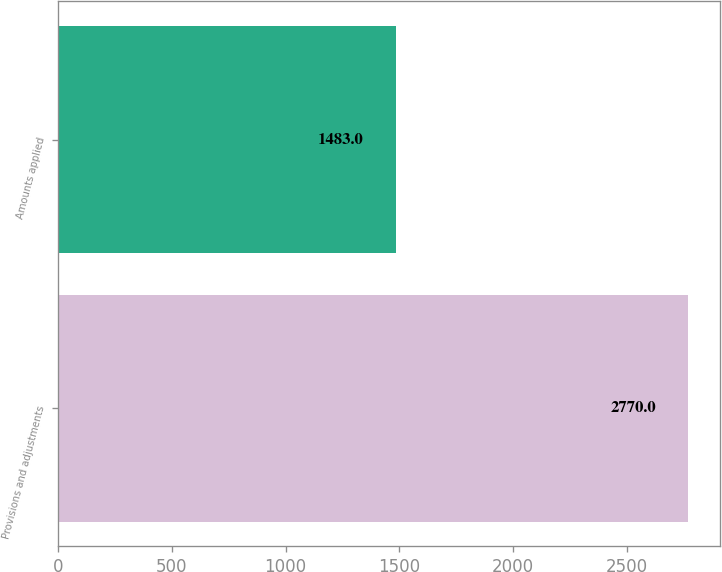<chart> <loc_0><loc_0><loc_500><loc_500><bar_chart><fcel>Provisions and adjustments<fcel>Amounts applied<nl><fcel>2770<fcel>1483<nl></chart> 